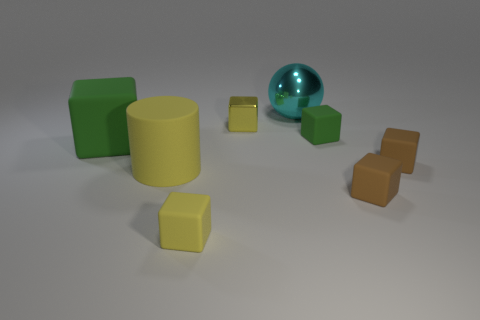There is a large object that is in front of the small shiny block and right of the big rubber block; what material is it?
Offer a very short reply. Rubber. What color is the other tiny metallic thing that is the same shape as the small green object?
Ensure brevity in your answer.  Yellow. The metallic cube is what size?
Your answer should be very brief. Small. There is a small matte thing that is behind the green rubber object to the left of the yellow matte cylinder; what color is it?
Provide a succinct answer. Green. What number of objects are in front of the large green object and behind the small metal cube?
Your response must be concise. 0. Is the number of big cyan matte cylinders greater than the number of yellow matte cubes?
Keep it short and to the point. No. What is the material of the big cylinder?
Give a very brief answer. Rubber. There is a green rubber object that is to the left of the large cyan shiny sphere; how many yellow metal blocks are on the left side of it?
Keep it short and to the point. 0. Is the color of the small metal object the same as the matte block that is behind the large rubber block?
Your answer should be very brief. No. There is a shiny cube that is the same size as the yellow rubber cube; what is its color?
Keep it short and to the point. Yellow. 